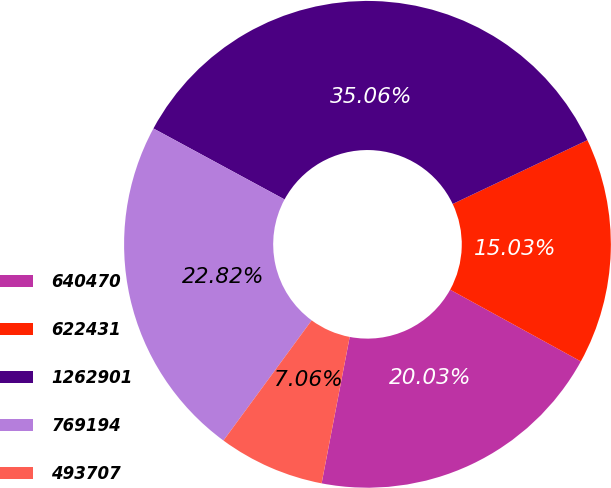<chart> <loc_0><loc_0><loc_500><loc_500><pie_chart><fcel>640470<fcel>622431<fcel>1262901<fcel>769194<fcel>493707<nl><fcel>20.03%<fcel>15.03%<fcel>35.06%<fcel>22.82%<fcel>7.06%<nl></chart> 